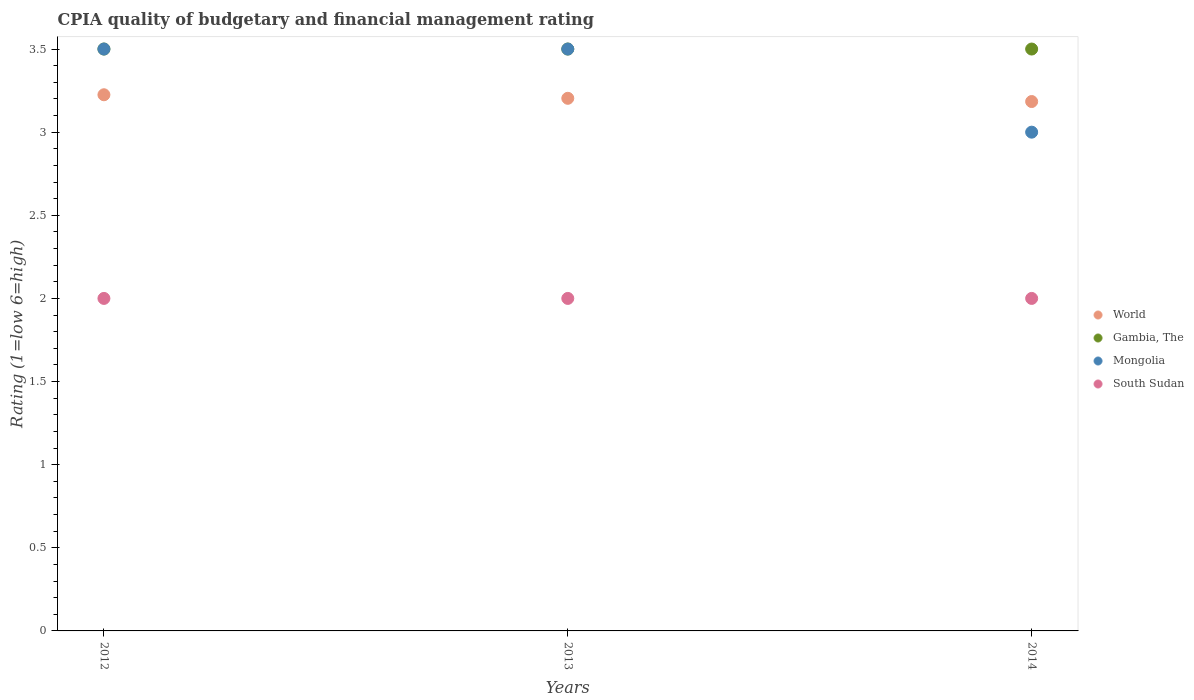Is the number of dotlines equal to the number of legend labels?
Your response must be concise. Yes. What is the CPIA rating in World in 2014?
Provide a short and direct response. 3.18. Across all years, what is the maximum CPIA rating in South Sudan?
Provide a short and direct response. 2. Across all years, what is the minimum CPIA rating in World?
Keep it short and to the point. 3.18. What is the total CPIA rating in South Sudan in the graph?
Give a very brief answer. 6. What is the difference between the CPIA rating in World in 2013 and the CPIA rating in Gambia, The in 2012?
Offer a very short reply. -0.3. What is the average CPIA rating in World per year?
Your answer should be very brief. 3.2. In the year 2014, what is the difference between the CPIA rating in World and CPIA rating in South Sudan?
Provide a succinct answer. 1.18. In how many years, is the CPIA rating in World greater than 0.5?
Make the answer very short. 3. Is the difference between the CPIA rating in World in 2013 and 2014 greater than the difference between the CPIA rating in South Sudan in 2013 and 2014?
Your response must be concise. Yes. What is the difference between the highest and the lowest CPIA rating in South Sudan?
Your answer should be very brief. 0. Is the CPIA rating in Mongolia strictly greater than the CPIA rating in World over the years?
Offer a very short reply. No. How many dotlines are there?
Your answer should be very brief. 4. How many years are there in the graph?
Make the answer very short. 3. What is the difference between two consecutive major ticks on the Y-axis?
Offer a terse response. 0.5. Are the values on the major ticks of Y-axis written in scientific E-notation?
Provide a short and direct response. No. Does the graph contain grids?
Keep it short and to the point. No. Where does the legend appear in the graph?
Keep it short and to the point. Center right. How many legend labels are there?
Provide a succinct answer. 4. What is the title of the graph?
Your answer should be very brief. CPIA quality of budgetary and financial management rating. Does "Tuvalu" appear as one of the legend labels in the graph?
Offer a terse response. No. What is the Rating (1=low 6=high) in World in 2012?
Your response must be concise. 3.23. What is the Rating (1=low 6=high) of Gambia, The in 2012?
Offer a very short reply. 3.5. What is the Rating (1=low 6=high) in South Sudan in 2012?
Ensure brevity in your answer.  2. What is the Rating (1=low 6=high) in World in 2013?
Provide a short and direct response. 3.2. What is the Rating (1=low 6=high) in World in 2014?
Your answer should be very brief. 3.18. What is the Rating (1=low 6=high) of Gambia, The in 2014?
Ensure brevity in your answer.  3.5. Across all years, what is the maximum Rating (1=low 6=high) in World?
Offer a very short reply. 3.23. Across all years, what is the maximum Rating (1=low 6=high) of Mongolia?
Provide a short and direct response. 3.5. Across all years, what is the maximum Rating (1=low 6=high) of South Sudan?
Offer a very short reply. 2. Across all years, what is the minimum Rating (1=low 6=high) in World?
Your answer should be very brief. 3.18. Across all years, what is the minimum Rating (1=low 6=high) in Mongolia?
Offer a very short reply. 3. Across all years, what is the minimum Rating (1=low 6=high) of South Sudan?
Give a very brief answer. 2. What is the total Rating (1=low 6=high) of World in the graph?
Offer a very short reply. 9.61. What is the total Rating (1=low 6=high) in South Sudan in the graph?
Provide a short and direct response. 6. What is the difference between the Rating (1=low 6=high) of World in 2012 and that in 2013?
Your response must be concise. 0.02. What is the difference between the Rating (1=low 6=high) in Mongolia in 2012 and that in 2013?
Offer a very short reply. 0. What is the difference between the Rating (1=low 6=high) of World in 2012 and that in 2014?
Make the answer very short. 0.04. What is the difference between the Rating (1=low 6=high) in Gambia, The in 2012 and that in 2014?
Make the answer very short. 0. What is the difference between the Rating (1=low 6=high) in South Sudan in 2012 and that in 2014?
Give a very brief answer. 0. What is the difference between the Rating (1=low 6=high) in World in 2013 and that in 2014?
Provide a succinct answer. 0.02. What is the difference between the Rating (1=low 6=high) of South Sudan in 2013 and that in 2014?
Your response must be concise. 0. What is the difference between the Rating (1=low 6=high) of World in 2012 and the Rating (1=low 6=high) of Gambia, The in 2013?
Give a very brief answer. -0.28. What is the difference between the Rating (1=low 6=high) in World in 2012 and the Rating (1=low 6=high) in Mongolia in 2013?
Provide a succinct answer. -0.28. What is the difference between the Rating (1=low 6=high) of World in 2012 and the Rating (1=low 6=high) of South Sudan in 2013?
Offer a very short reply. 1.23. What is the difference between the Rating (1=low 6=high) of World in 2012 and the Rating (1=low 6=high) of Gambia, The in 2014?
Give a very brief answer. -0.28. What is the difference between the Rating (1=low 6=high) in World in 2012 and the Rating (1=low 6=high) in Mongolia in 2014?
Your answer should be very brief. 0.23. What is the difference between the Rating (1=low 6=high) of World in 2012 and the Rating (1=low 6=high) of South Sudan in 2014?
Offer a terse response. 1.23. What is the difference between the Rating (1=low 6=high) of Gambia, The in 2012 and the Rating (1=low 6=high) of Mongolia in 2014?
Keep it short and to the point. 0.5. What is the difference between the Rating (1=low 6=high) of Mongolia in 2012 and the Rating (1=low 6=high) of South Sudan in 2014?
Provide a short and direct response. 1.5. What is the difference between the Rating (1=low 6=high) in World in 2013 and the Rating (1=low 6=high) in Gambia, The in 2014?
Give a very brief answer. -0.3. What is the difference between the Rating (1=low 6=high) of World in 2013 and the Rating (1=low 6=high) of Mongolia in 2014?
Provide a short and direct response. 0.2. What is the difference between the Rating (1=low 6=high) of World in 2013 and the Rating (1=low 6=high) of South Sudan in 2014?
Provide a succinct answer. 1.2. What is the difference between the Rating (1=low 6=high) of Gambia, The in 2013 and the Rating (1=low 6=high) of South Sudan in 2014?
Offer a very short reply. 1.5. What is the average Rating (1=low 6=high) in World per year?
Keep it short and to the point. 3.2. What is the average Rating (1=low 6=high) of Mongolia per year?
Your response must be concise. 3.33. In the year 2012, what is the difference between the Rating (1=low 6=high) in World and Rating (1=low 6=high) in Gambia, The?
Your answer should be very brief. -0.28. In the year 2012, what is the difference between the Rating (1=low 6=high) in World and Rating (1=low 6=high) in Mongolia?
Make the answer very short. -0.28. In the year 2012, what is the difference between the Rating (1=low 6=high) of World and Rating (1=low 6=high) of South Sudan?
Provide a succinct answer. 1.23. In the year 2012, what is the difference between the Rating (1=low 6=high) of Gambia, The and Rating (1=low 6=high) of South Sudan?
Your response must be concise. 1.5. In the year 2012, what is the difference between the Rating (1=low 6=high) in Mongolia and Rating (1=low 6=high) in South Sudan?
Provide a succinct answer. 1.5. In the year 2013, what is the difference between the Rating (1=low 6=high) of World and Rating (1=low 6=high) of Gambia, The?
Offer a very short reply. -0.3. In the year 2013, what is the difference between the Rating (1=low 6=high) of World and Rating (1=low 6=high) of Mongolia?
Keep it short and to the point. -0.3. In the year 2013, what is the difference between the Rating (1=low 6=high) in World and Rating (1=low 6=high) in South Sudan?
Ensure brevity in your answer.  1.2. In the year 2013, what is the difference between the Rating (1=low 6=high) of Gambia, The and Rating (1=low 6=high) of South Sudan?
Give a very brief answer. 1.5. In the year 2014, what is the difference between the Rating (1=low 6=high) of World and Rating (1=low 6=high) of Gambia, The?
Your answer should be compact. -0.32. In the year 2014, what is the difference between the Rating (1=low 6=high) of World and Rating (1=low 6=high) of Mongolia?
Your answer should be compact. 0.18. In the year 2014, what is the difference between the Rating (1=low 6=high) in World and Rating (1=low 6=high) in South Sudan?
Keep it short and to the point. 1.18. In the year 2014, what is the difference between the Rating (1=low 6=high) in Gambia, The and Rating (1=low 6=high) in South Sudan?
Ensure brevity in your answer.  1.5. What is the ratio of the Rating (1=low 6=high) of World in 2012 to that in 2013?
Make the answer very short. 1.01. What is the ratio of the Rating (1=low 6=high) of South Sudan in 2012 to that in 2013?
Provide a short and direct response. 1. What is the ratio of the Rating (1=low 6=high) in World in 2012 to that in 2014?
Your answer should be very brief. 1.01. What is the ratio of the Rating (1=low 6=high) of Mongolia in 2012 to that in 2014?
Your answer should be compact. 1.17. What is the ratio of the Rating (1=low 6=high) in World in 2013 to that in 2014?
Your response must be concise. 1.01. What is the ratio of the Rating (1=low 6=high) of Gambia, The in 2013 to that in 2014?
Your answer should be compact. 1. What is the difference between the highest and the second highest Rating (1=low 6=high) of World?
Give a very brief answer. 0.02. What is the difference between the highest and the second highest Rating (1=low 6=high) in Gambia, The?
Ensure brevity in your answer.  0. What is the difference between the highest and the second highest Rating (1=low 6=high) in South Sudan?
Ensure brevity in your answer.  0. What is the difference between the highest and the lowest Rating (1=low 6=high) of World?
Make the answer very short. 0.04. What is the difference between the highest and the lowest Rating (1=low 6=high) of Mongolia?
Provide a short and direct response. 0.5. What is the difference between the highest and the lowest Rating (1=low 6=high) of South Sudan?
Your answer should be compact. 0. 